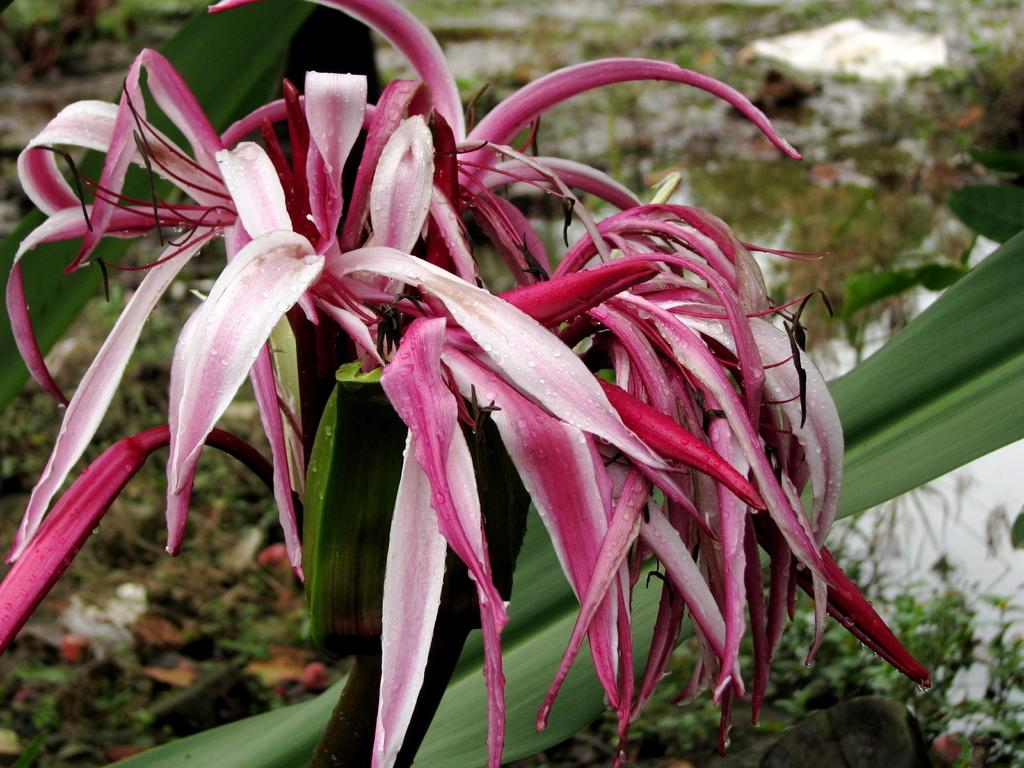What type of plant is in the image? The plant in the image has pink color leaves. What other natural elements can be seen in the image? There is grass and water visible in the image. Are there any boats visible in the image? No, there are no boats present in the image. What type of glove can be seen in the image? There is no glove present in the image. 